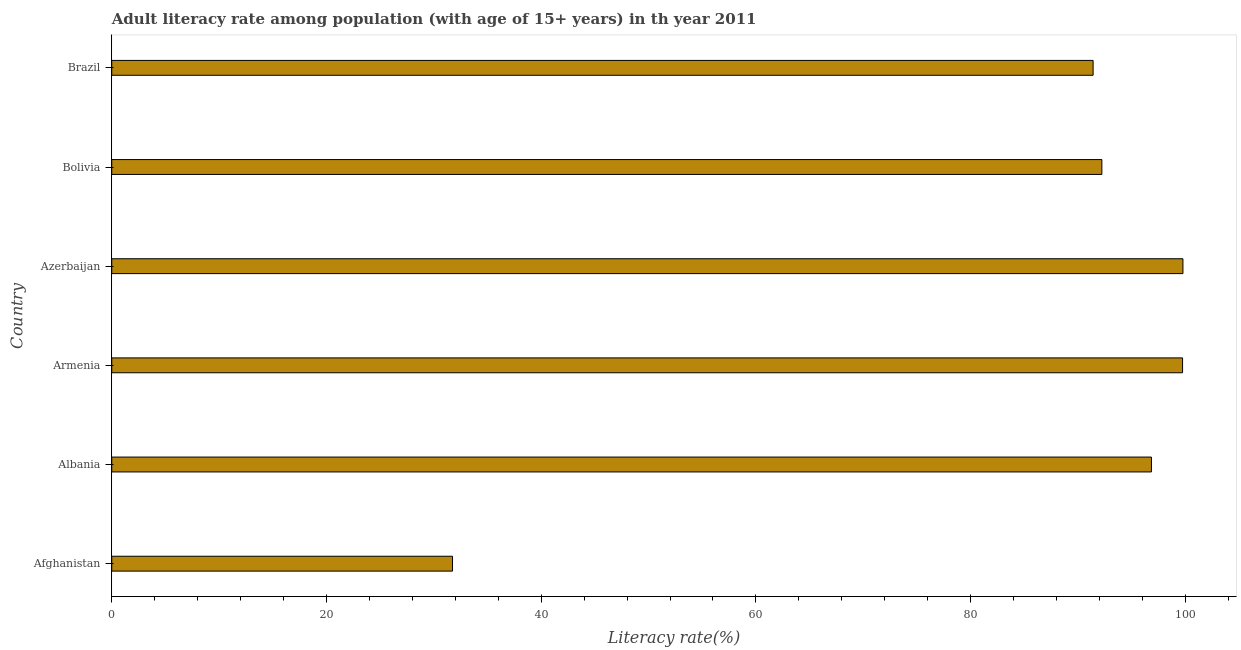Does the graph contain any zero values?
Your answer should be very brief. No. Does the graph contain grids?
Offer a very short reply. No. What is the title of the graph?
Offer a very short reply. Adult literacy rate among population (with age of 15+ years) in th year 2011. What is the label or title of the X-axis?
Your response must be concise. Literacy rate(%). What is the adult literacy rate in Brazil?
Ensure brevity in your answer.  91.41. Across all countries, what is the maximum adult literacy rate?
Keep it short and to the point. 99.78. Across all countries, what is the minimum adult literacy rate?
Your answer should be compact. 31.74. In which country was the adult literacy rate maximum?
Give a very brief answer. Azerbaijan. In which country was the adult literacy rate minimum?
Your answer should be compact. Afghanistan. What is the sum of the adult literacy rate?
Offer a terse response. 511.75. What is the difference between the adult literacy rate in Armenia and Azerbaijan?
Provide a short and direct response. -0.03. What is the average adult literacy rate per country?
Your answer should be very brief. 85.29. What is the median adult literacy rate?
Your answer should be very brief. 94.54. Is the adult literacy rate in Azerbaijan less than that in Bolivia?
Give a very brief answer. No. What is the difference between the highest and the second highest adult literacy rate?
Make the answer very short. 0.03. Is the sum of the adult literacy rate in Azerbaijan and Bolivia greater than the maximum adult literacy rate across all countries?
Your answer should be compact. Yes. What is the difference between the highest and the lowest adult literacy rate?
Your response must be concise. 68.04. In how many countries, is the adult literacy rate greater than the average adult literacy rate taken over all countries?
Your response must be concise. 5. How many bars are there?
Offer a terse response. 6. Are the values on the major ticks of X-axis written in scientific E-notation?
Provide a short and direct response. No. What is the Literacy rate(%) in Afghanistan?
Ensure brevity in your answer.  31.74. What is the Literacy rate(%) of Albania?
Give a very brief answer. 96.85. What is the Literacy rate(%) of Armenia?
Offer a terse response. 99.74. What is the Literacy rate(%) in Azerbaijan?
Keep it short and to the point. 99.78. What is the Literacy rate(%) of Bolivia?
Provide a short and direct response. 92.23. What is the Literacy rate(%) of Brazil?
Your answer should be very brief. 91.41. What is the difference between the Literacy rate(%) in Afghanistan and Albania?
Provide a short and direct response. -65.1. What is the difference between the Literacy rate(%) in Afghanistan and Armenia?
Your response must be concise. -68. What is the difference between the Literacy rate(%) in Afghanistan and Azerbaijan?
Give a very brief answer. -68.04. What is the difference between the Literacy rate(%) in Afghanistan and Bolivia?
Your answer should be compact. -60.49. What is the difference between the Literacy rate(%) in Afghanistan and Brazil?
Offer a terse response. -59.67. What is the difference between the Literacy rate(%) in Albania and Armenia?
Your response must be concise. -2.9. What is the difference between the Literacy rate(%) in Albania and Azerbaijan?
Ensure brevity in your answer.  -2.93. What is the difference between the Literacy rate(%) in Albania and Bolivia?
Provide a succinct answer. 4.62. What is the difference between the Literacy rate(%) in Albania and Brazil?
Offer a very short reply. 5.43. What is the difference between the Literacy rate(%) in Armenia and Azerbaijan?
Your response must be concise. -0.03. What is the difference between the Literacy rate(%) in Armenia and Bolivia?
Your answer should be very brief. 7.52. What is the difference between the Literacy rate(%) in Armenia and Brazil?
Your response must be concise. 8.33. What is the difference between the Literacy rate(%) in Azerbaijan and Bolivia?
Your response must be concise. 7.55. What is the difference between the Literacy rate(%) in Azerbaijan and Brazil?
Provide a short and direct response. 8.37. What is the difference between the Literacy rate(%) in Bolivia and Brazil?
Give a very brief answer. 0.81. What is the ratio of the Literacy rate(%) in Afghanistan to that in Albania?
Give a very brief answer. 0.33. What is the ratio of the Literacy rate(%) in Afghanistan to that in Armenia?
Provide a short and direct response. 0.32. What is the ratio of the Literacy rate(%) in Afghanistan to that in Azerbaijan?
Provide a succinct answer. 0.32. What is the ratio of the Literacy rate(%) in Afghanistan to that in Bolivia?
Your answer should be compact. 0.34. What is the ratio of the Literacy rate(%) in Afghanistan to that in Brazil?
Ensure brevity in your answer.  0.35. What is the ratio of the Literacy rate(%) in Albania to that in Bolivia?
Your answer should be compact. 1.05. What is the ratio of the Literacy rate(%) in Albania to that in Brazil?
Your response must be concise. 1.06. What is the ratio of the Literacy rate(%) in Armenia to that in Bolivia?
Ensure brevity in your answer.  1.08. What is the ratio of the Literacy rate(%) in Armenia to that in Brazil?
Give a very brief answer. 1.09. What is the ratio of the Literacy rate(%) in Azerbaijan to that in Bolivia?
Provide a short and direct response. 1.08. What is the ratio of the Literacy rate(%) in Azerbaijan to that in Brazil?
Keep it short and to the point. 1.09. 